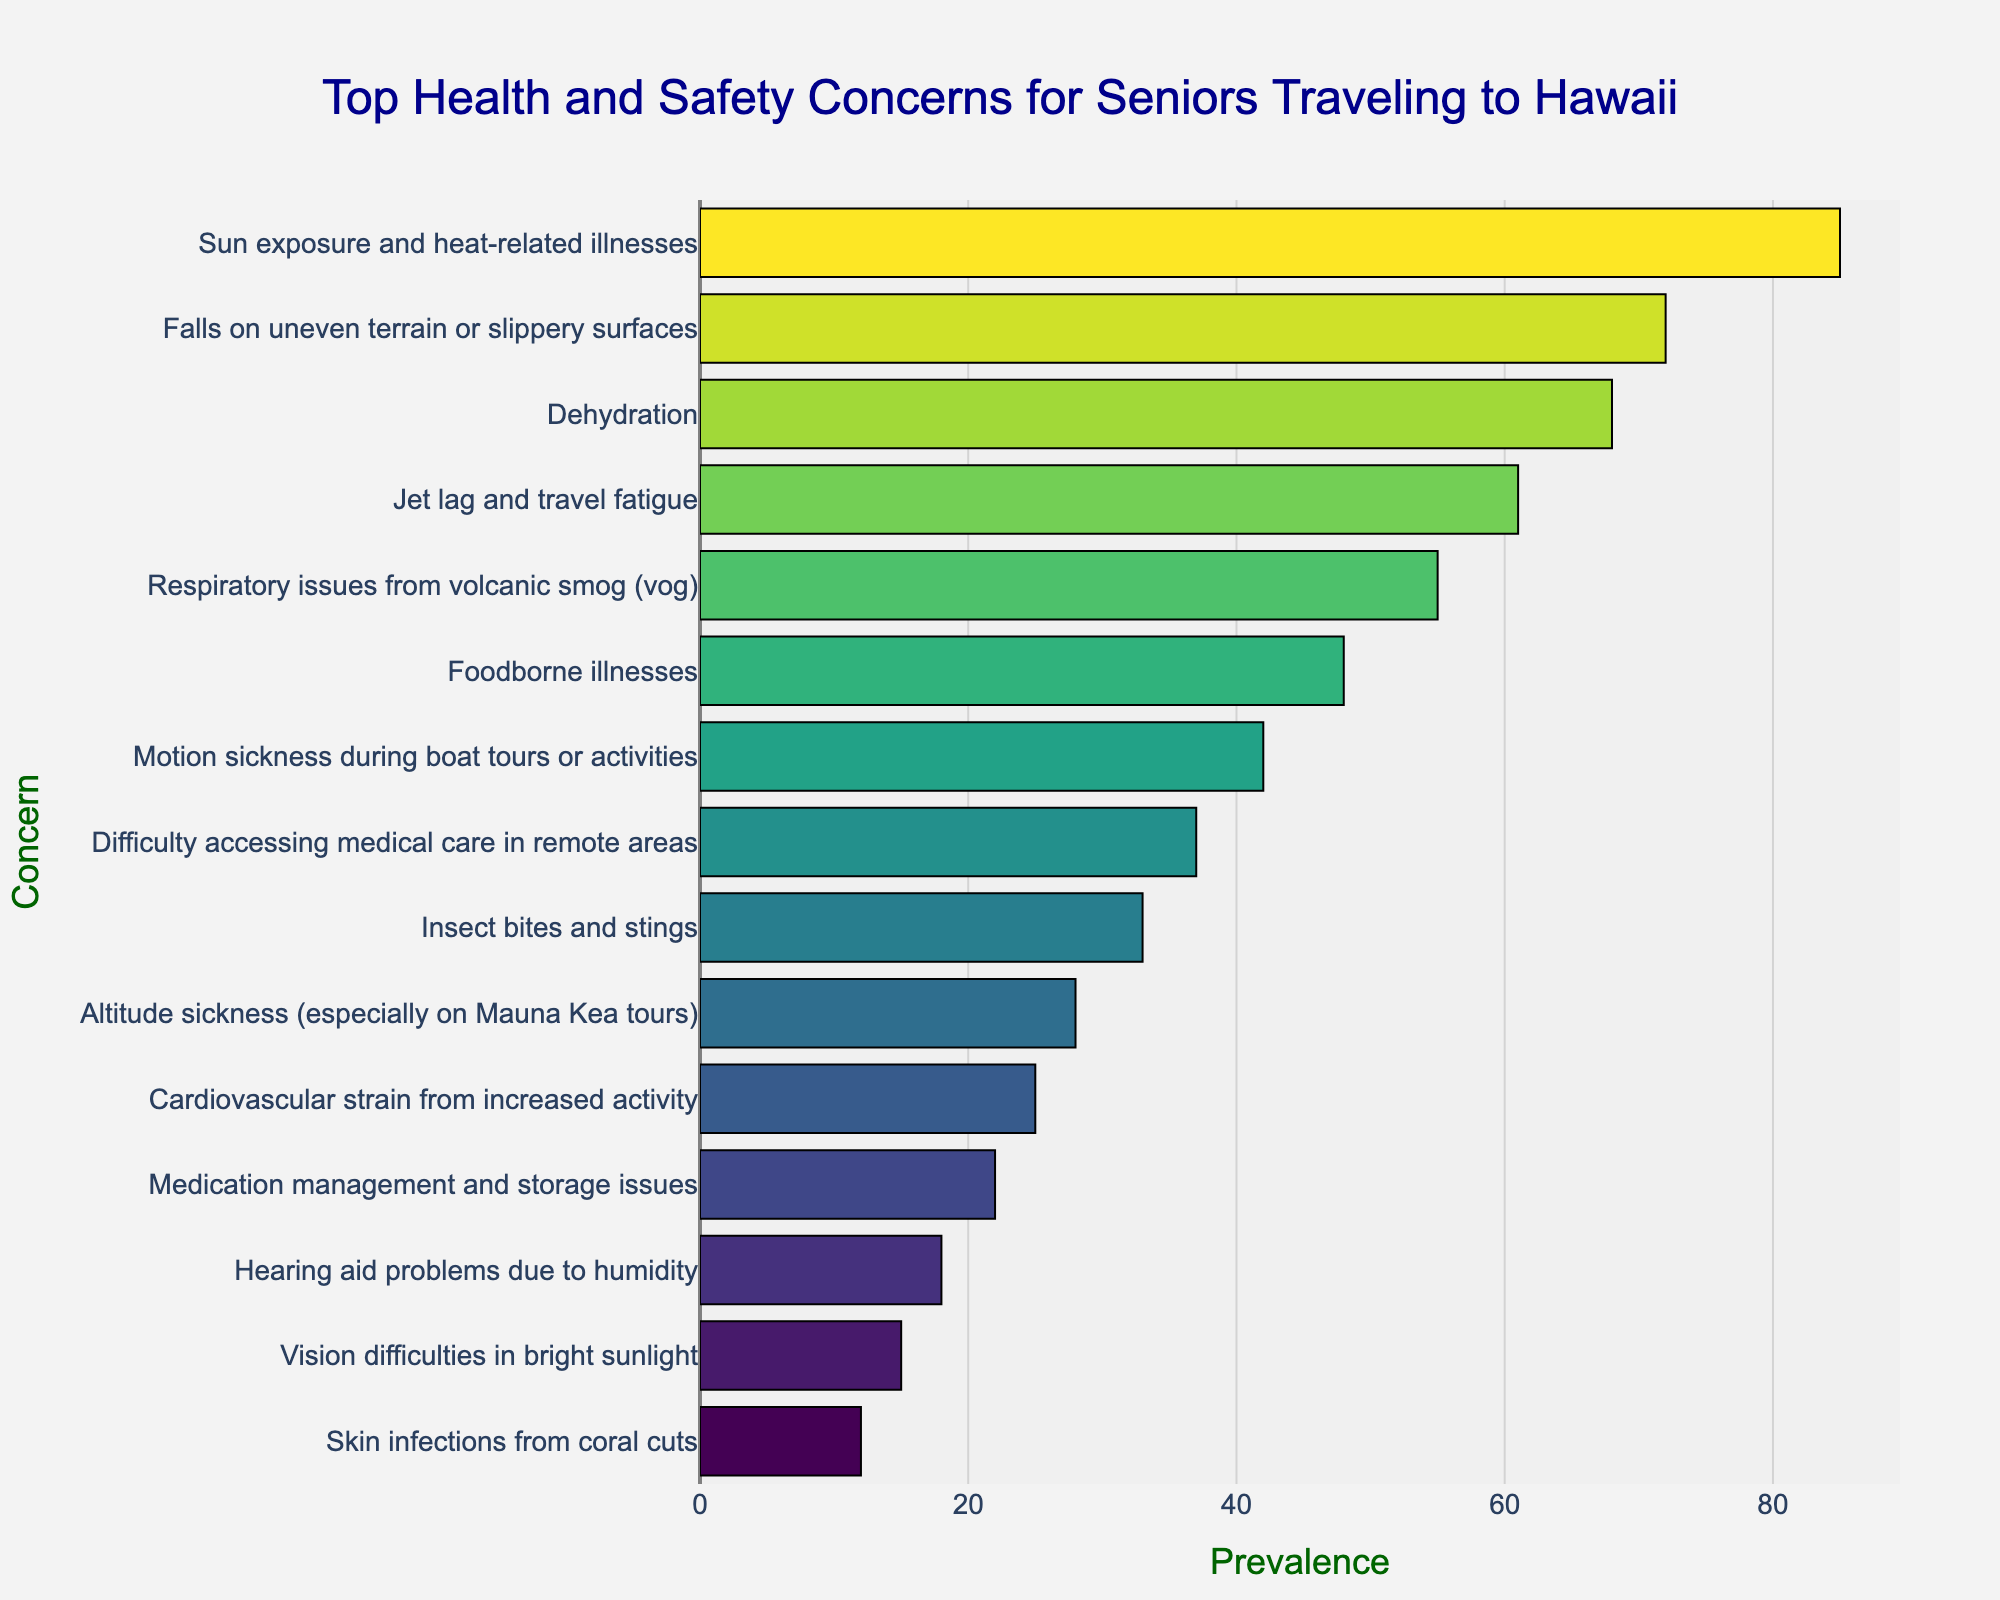What is the most prevalent health and safety concern for seniors traveling to Hawaii? The longest bar in the chart represents the most prevalent concern. "Sun exposure and heat-related illnesses" has the highest prevalence with a value of 85.
Answer: Sun exposure and heat-related illnesses Which health and safety concern has a prevalence of 61? Locate the bar with a value of 61. "Jet lag and travel fatigue" is the concern with a prevalence of 61.
Answer: Jet lag and travel fatigue Compare the prevalence of "Falls on uneven terrain or slippery surfaces" and "Dehydration". Which one is higher? "Falls on uneven terrain or slippery surfaces" has a prevalence of 72, and "Dehydration" has a prevalence of 68. The comparison shows that 72 is higher than 68.
Answer: Falls on uneven terrain or slippery surfaces What is the combined prevalence of "Foodborne illnesses" and "Motion sickness during boat tours or activities"? Add the prevalences of "Foodborne illnesses" (48) and "Motion sickness during boat tours or activities" (42). The sum is 48 + 42 = 90.
Answer: 90 Which health concern has the lowest prevalence, and what is its value? The shortest bar represents the lowest prevalence. "Skin infections from coral cuts" has the lowest prevalence with a value of 12.
Answer: Skin infections from coral cuts, 12 What is the difference in prevalence between "Insect bites and stings" and "Cardiovascular strain from increased activity"? The prevalence of "Insect bites and stings" is 33, and the prevalence of "Cardiovascular strain from increased activity" is 25. The difference is 33 - 25 = 8.
Answer: 8 Which concern has a prevalence twice as high as "Hearing aid problems due to humidity"? "Hearing aid problems due to humidity" has a prevalence of 18. Twice this value is 18 * 2 = 36. The closest matching concern is "Difficulty accessing medical care in remote areas" with a prevalence of 37.
Answer: Difficulty accessing medical care in remote areas What is the average prevalence of the top three health concerns? The top three health concerns are "Sun exposure and heat-related illnesses" (85), "Falls on uneven terrain or slippery surfaces" (72), and "Dehydration" (68). The average is calculated as (85 + 72 + 68) / 3 = 75.
Answer: 75 